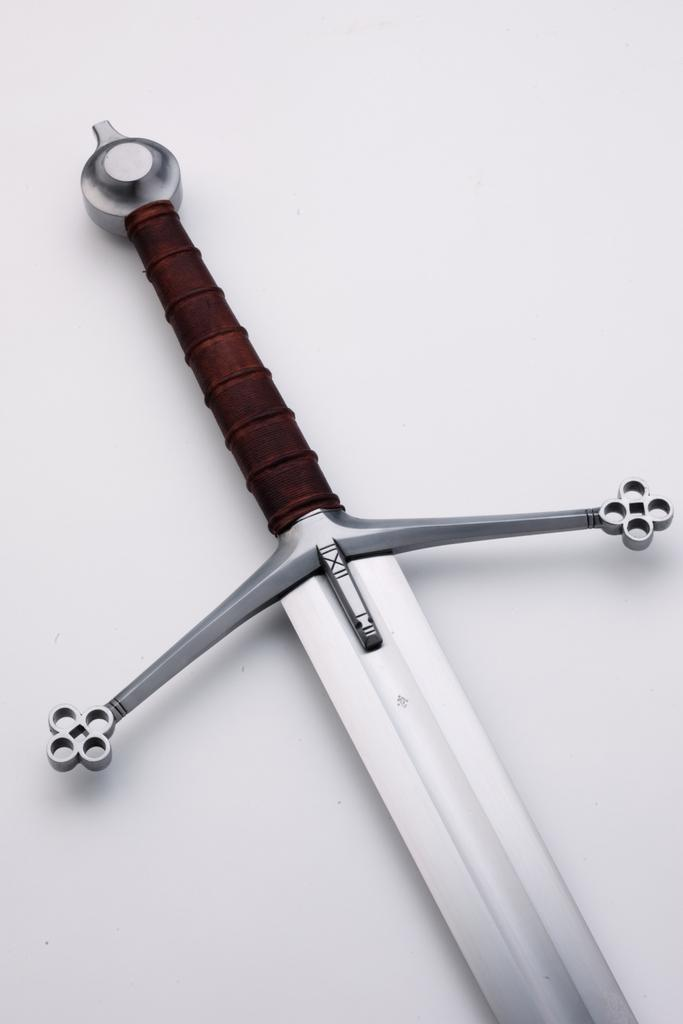What object in the image can be used as a weapon? There is a weapon in the image, but its specific type cannot be determined from the provided facts. What color is the background of the image? The background of the image is white. What type of furniture is present in the image? There is no furniture mentioned or visible in the image. How is the weapon connected to the background in the image? The weapon is not connected to the background in the image; it is simply placed against the white background. 